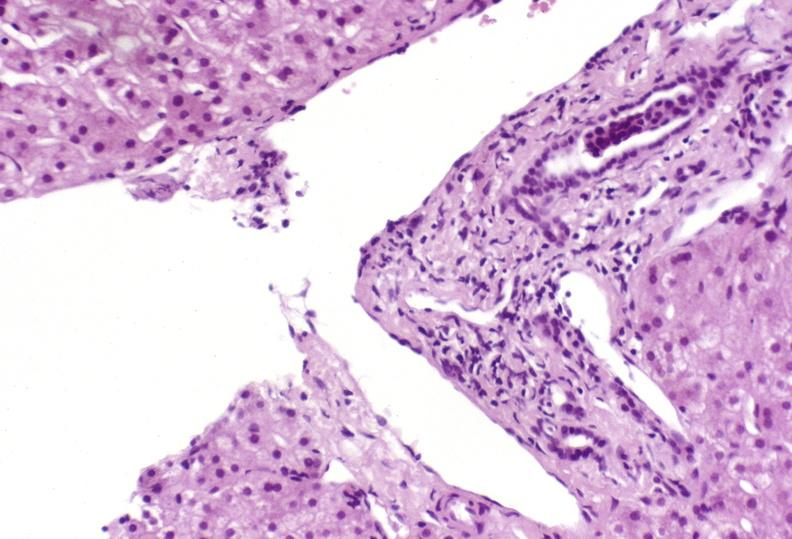what is present?
Answer the question using a single word or phrase. Liver 